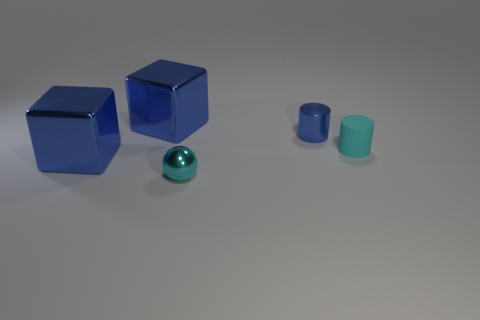What color is the thing that is right of the blue cylinder?
Keep it short and to the point. Cyan. Do the cylinder to the left of the cyan rubber object and the cyan matte cylinder have the same size?
Keep it short and to the point. Yes. Is there a yellow rubber cube that has the same size as the cyan metal thing?
Provide a short and direct response. No. Does the metallic object that is right of the tiny cyan ball have the same color as the big block that is behind the tiny matte thing?
Your answer should be very brief. Yes. Are there any metal spheres of the same color as the rubber cylinder?
Provide a succinct answer. Yes. How many other objects are the same shape as the tiny matte thing?
Your response must be concise. 1. What shape is the tiny thing that is in front of the tiny cyan cylinder?
Offer a very short reply. Sphere. There is a tiny cyan rubber object; does it have the same shape as the small metal thing in front of the cyan matte cylinder?
Keep it short and to the point. No. There is a object that is on the left side of the matte object and to the right of the metal sphere; what size is it?
Your response must be concise. Small. There is a thing that is behind the cyan cylinder and to the left of the small blue cylinder; what color is it?
Provide a succinct answer. Blue. 